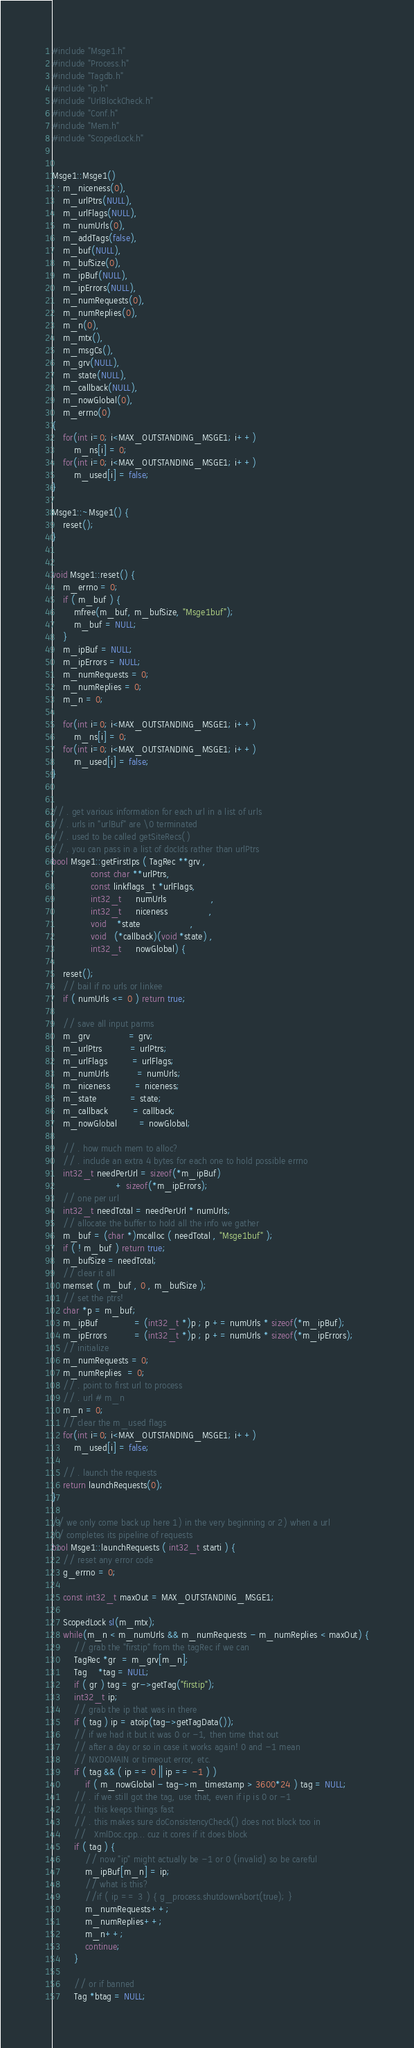Convert code to text. <code><loc_0><loc_0><loc_500><loc_500><_C++_>#include "Msge1.h"
#include "Process.h"
#include "Tagdb.h"
#include "ip.h"
#include "UrlBlockCheck.h"
#include "Conf.h"
#include "Mem.h"
#include "ScopedLock.h"


Msge1::Msge1()
  : m_niceness(0),
    m_urlPtrs(NULL),
    m_urlFlags(NULL),
    m_numUrls(0),
    m_addTags(false),
    m_buf(NULL),
    m_bufSize(0),
    m_ipBuf(NULL),
    m_ipErrors(NULL),
    m_numRequests(0),
    m_numReplies(0),
    m_n(0),
    m_mtx(),
    m_msgCs(),
    m_grv(NULL),
    m_state(NULL),
    m_callback(NULL),
    m_nowGlobal(0),
    m_errno(0)
{
	for(int i=0; i<MAX_OUTSTANDING_MSGE1; i++)
		m_ns[i] = 0;
	for(int i=0; i<MAX_OUTSTANDING_MSGE1; i++)
		m_used[i] = false;
}

Msge1::~Msge1() {
	reset();
}


void Msge1::reset() {
	m_errno = 0;
	if ( m_buf ) {
		mfree(m_buf, m_bufSize, "Msge1buf");
		m_buf = NULL;
	}
	m_ipBuf = NULL;
	m_ipErrors = NULL;
	m_numRequests = 0;
	m_numReplies = 0;
	m_n = 0;
	
	for(int i=0; i<MAX_OUTSTANDING_MSGE1; i++)
		m_ns[i] = 0;
	for(int i=0; i<MAX_OUTSTANDING_MSGE1; i++)
		m_used[i] = false;
}


// . get various information for each url in a list of urls
// . urls in "urlBuf" are \0 terminated
// . used to be called getSiteRecs()
// . you can pass in a list of docIds rather than urlPtrs
bool Msge1::getFirstIps ( TagRec **grv ,
			  const char **urlPtrs,
			  const linkflags_t *urlFlags,
			  int32_t     numUrls                ,
			  int32_t     niceness               ,
			  void    *state                  ,
			  void   (*callback)(void *state) ,
			  int32_t     nowGlobal) {

	reset();
	// bail if no urls or linkee
	if ( numUrls <= 0 ) return true;

	// save all input parms
	m_grv              = grv;
	m_urlPtrs          = urlPtrs;
	m_urlFlags         = urlFlags;
	m_numUrls          = numUrls;
	m_niceness         = niceness;
	m_state            = state;
	m_callback         = callback;
	m_nowGlobal        = nowGlobal;

	// . how much mem to alloc?
	// . include an extra 4 bytes for each one to hold possible errno
	int32_t needPerUrl = sizeof(*m_ipBuf)
	                   + sizeof(*m_ipErrors);
	// one per url
	int32_t needTotal = needPerUrl * numUrls;
	// allocate the buffer to hold all the info we gather
	m_buf = (char *)mcalloc ( needTotal , "Msge1buf" );
	if ( ! m_buf ) return true;
	m_bufSize = needTotal;
	// clear it all
	memset ( m_buf , 0 , m_bufSize );
	// set the ptrs!
	char *p = m_buf;
	m_ipBuf             = (int32_t *)p ; p += numUrls * sizeof(*m_ipBuf);
	m_ipErrors          = (int32_t *)p ; p += numUrls * sizeof(*m_ipErrors);
	// initialize
	m_numRequests = 0;
	m_numReplies  = 0;
	// . point to first url to process
	// . url # m_n
	m_n = 0;
	// clear the m_used flags
	for(int i=0; i<MAX_OUTSTANDING_MSGE1; i++)
		m_used[i] = false;

	// . launch the requests
	return launchRequests(0);
}

// we only come back up here 1) in the very beginning or 2) when a url 
// completes its pipeline of requests
bool Msge1::launchRequests ( int32_t starti ) {
	// reset any error code
	g_errno = 0;

	const int32_t maxOut = MAX_OUTSTANDING_MSGE1;

	ScopedLock sl(m_mtx);
	while(m_n < m_numUrls && m_numRequests - m_numReplies < maxOut) {
		// grab the "firstip" from the tagRec if we can
		TagRec *gr  = m_grv[m_n];
		Tag    *tag = NULL;
		if ( gr ) tag = gr->getTag("firstip");
		int32_t ip;
		// grab the ip that was in there
		if ( tag ) ip = atoip(tag->getTagData());
		// if we had it but it was 0 or -1, then time that out
		// after a day or so in case it works again! 0 and -1 mean
		// NXDOMAIN or timeout error, etc.
		if ( tag && ( ip == 0 || ip == -1 ) )
			if ( m_nowGlobal - tag->m_timestamp > 3600*24 ) tag = NULL;
		// . if we still got the tag, use that, even if ip is 0 or -1
		// . this keeps things fast
		// . this makes sure doConsistencyCheck() does not block too in
		//   XmlDoc.cpp... cuz it cores if it does block
		if ( tag ) {
			// now "ip" might actually be -1 or 0 (invalid) so be careful
			m_ipBuf[m_n] = ip;
			// what is this?
			//if ( ip == 3 ) { g_process.shutdownAbort(true); }
			m_numRequests++;
			m_numReplies++;
			m_n++;
			continue;
		}

		// or if banned
		Tag *btag = NULL;</code> 